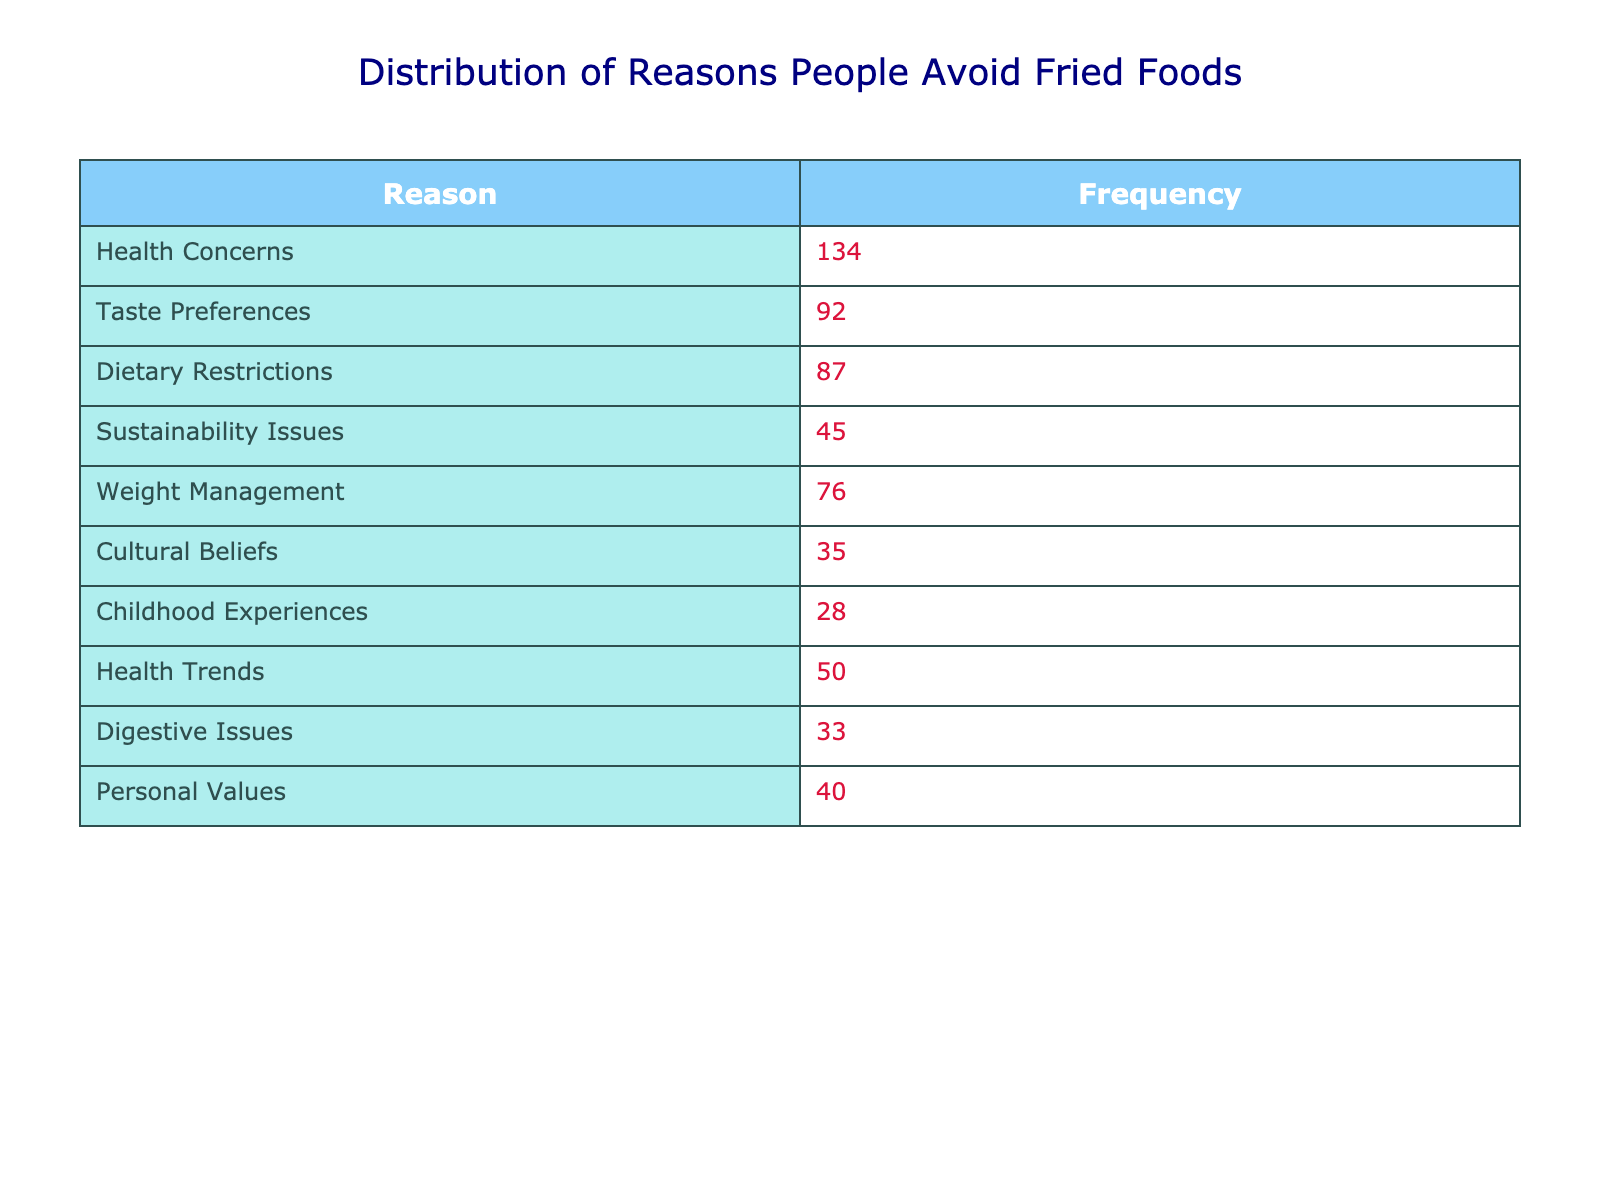What's the most common reason people avoid fried foods? The table shows that the highest frequency is linked to "Health Concerns" with a value of 134.
Answer: Health Concerns How many people avoid fried foods due to Taste Preferences? According to the table, the frequency for "Taste Preferences" is explicitly listed as 92.
Answer: 92 What is the total frequency of people avoiding fried foods for Weight Management and Dietary Restrictions combined? The total frequency for "Weight Management" is 76 and for "Dietary Restrictions" is 87. By adding these together: 76 + 87 = 163.
Answer: 163 Is there a greater number of people who cite Health Trends or Sustainability Issues as reasons for avoiding fried foods? The table shows that "Health Trends" has a frequency of 50 and "Sustainability Issues" has 45, making "Health Trends" the higher count.
Answer: Yes What is the frequency difference between the reasons based on Childhood Experiences and Cultural Beliefs? "Childhood Experiences" has a frequency of 28 and "Cultural Beliefs" has 35. Subtracting these gives: 35 - 28 = 7, indicating that more people cite Cultural Beliefs.
Answer: 7 What proportion of the total frequency do the reasons related to personal values and sustainability issues represent? The total frequencies for "Personal Values" (40) and "Sustainability Issues" (45) add up to 85. To find the total frequency of all reasons, sum all values (134 + 92 + 87 + 45 + 76 + 35 + 28 + 50 + 33 + 40 =  600). The proportion is then calculated as (85 / 600) × 100 = 14.17%.
Answer: 14.17% Which category has the least amount of avoidance reported, and how many reported it? The frequencies of reasons are listed, and the lowest frequency is "Childhood Experiences" at 28.
Answer: Childhood Experiences, 28 Can we say that more people avoid fried foods for health-related reasons compared to those who avoid it for personal values or cultural beliefs combined? "Health Concerns" (134) is significantly higher than the combined values of "Personal Values" (40) and "Cultural Beliefs" (35), totaling 75. Since 134 > 75, we conclude more avoid fried foods due to health reasons.
Answer: Yes 